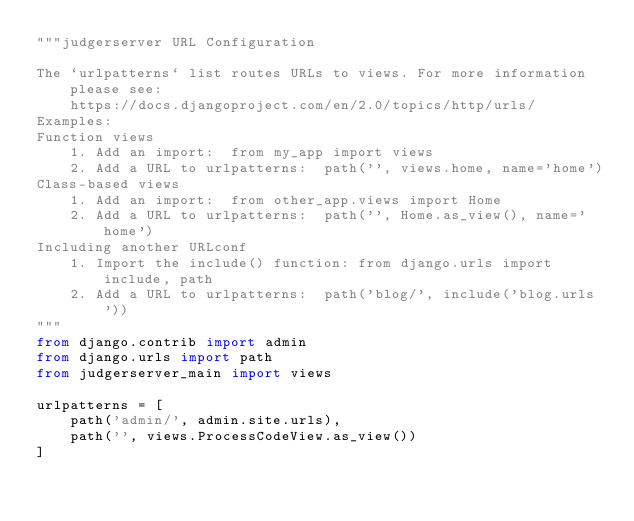Convert code to text. <code><loc_0><loc_0><loc_500><loc_500><_Python_>"""judgerserver URL Configuration

The `urlpatterns` list routes URLs to views. For more information please see:
    https://docs.djangoproject.com/en/2.0/topics/http/urls/
Examples:
Function views
    1. Add an import:  from my_app import views
    2. Add a URL to urlpatterns:  path('', views.home, name='home')
Class-based views
    1. Add an import:  from other_app.views import Home
    2. Add a URL to urlpatterns:  path('', Home.as_view(), name='home')
Including another URLconf
    1. Import the include() function: from django.urls import include, path
    2. Add a URL to urlpatterns:  path('blog/', include('blog.urls'))
"""
from django.contrib import admin
from django.urls import path
from judgerserver_main import views

urlpatterns = [
    path('admin/', admin.site.urls),
    path('', views.ProcessCodeView.as_view())
]
</code> 